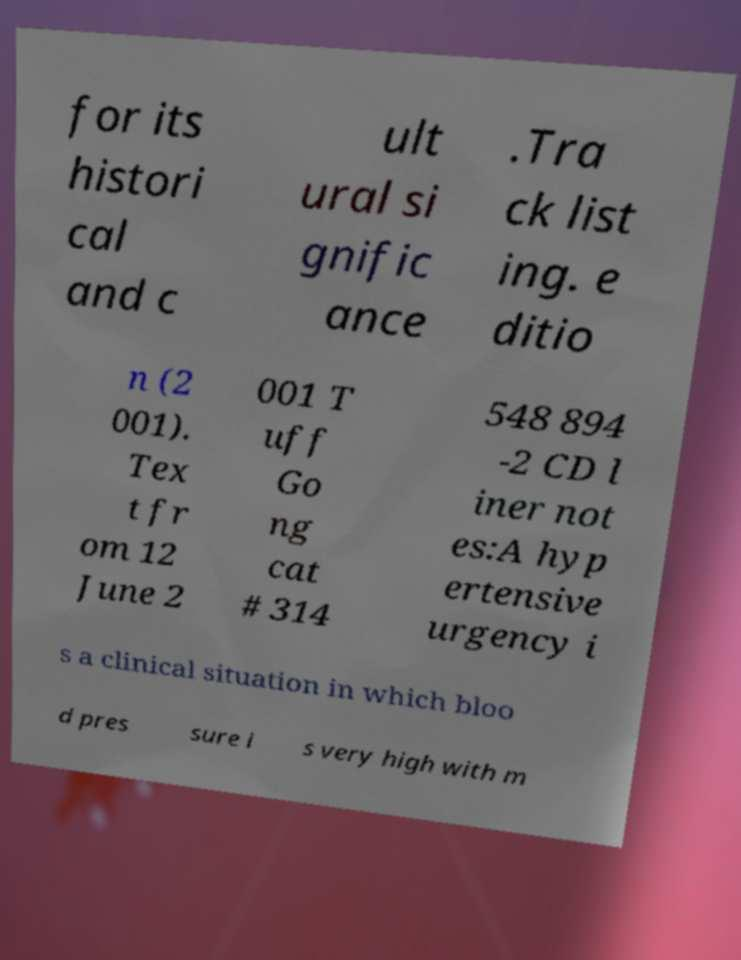Please read and relay the text visible in this image. What does it say? for its histori cal and c ult ural si gnific ance .Tra ck list ing. e ditio n (2 001). Tex t fr om 12 June 2 001 T uff Go ng cat # 314 548 894 -2 CD l iner not es:A hyp ertensive urgency i s a clinical situation in which bloo d pres sure i s very high with m 